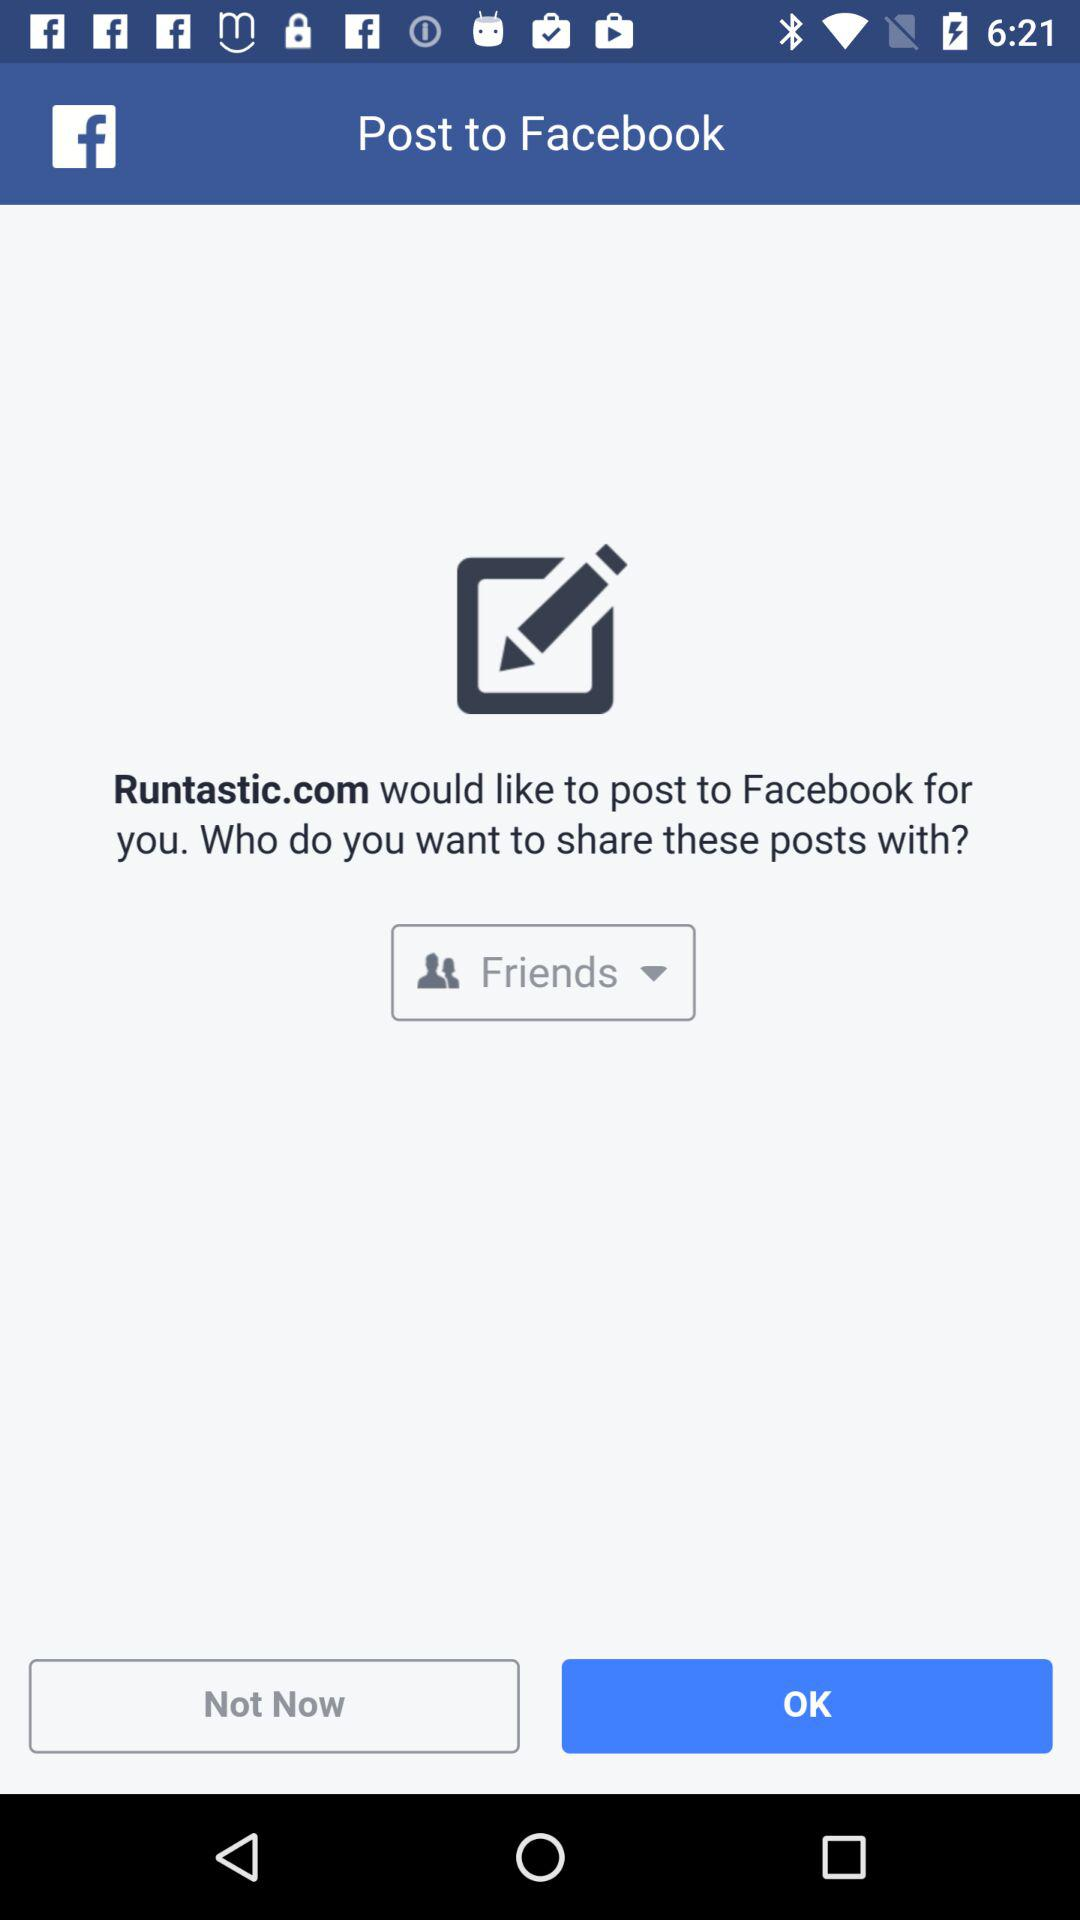Which option is selected to share these posts with? The selected option to share these posts with is "Friends". 